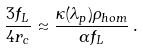<formula> <loc_0><loc_0><loc_500><loc_500>\frac { 3 f _ { L } } { 4 r _ { c } } \approx \frac { \kappa ( \lambda _ { p } ) \rho _ { h o m } } { \alpha f _ { L } } \, .</formula> 